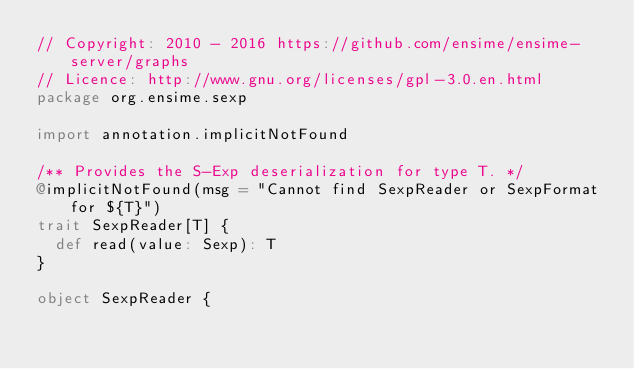<code> <loc_0><loc_0><loc_500><loc_500><_Scala_>// Copyright: 2010 - 2016 https://github.com/ensime/ensime-server/graphs
// Licence: http://www.gnu.org/licenses/gpl-3.0.en.html
package org.ensime.sexp

import annotation.implicitNotFound

/** Provides the S-Exp deserialization for type T. */
@implicitNotFound(msg = "Cannot find SexpReader or SexpFormat for ${T}")
trait SexpReader[T] {
  def read(value: Sexp): T
}

object SexpReader {</code> 